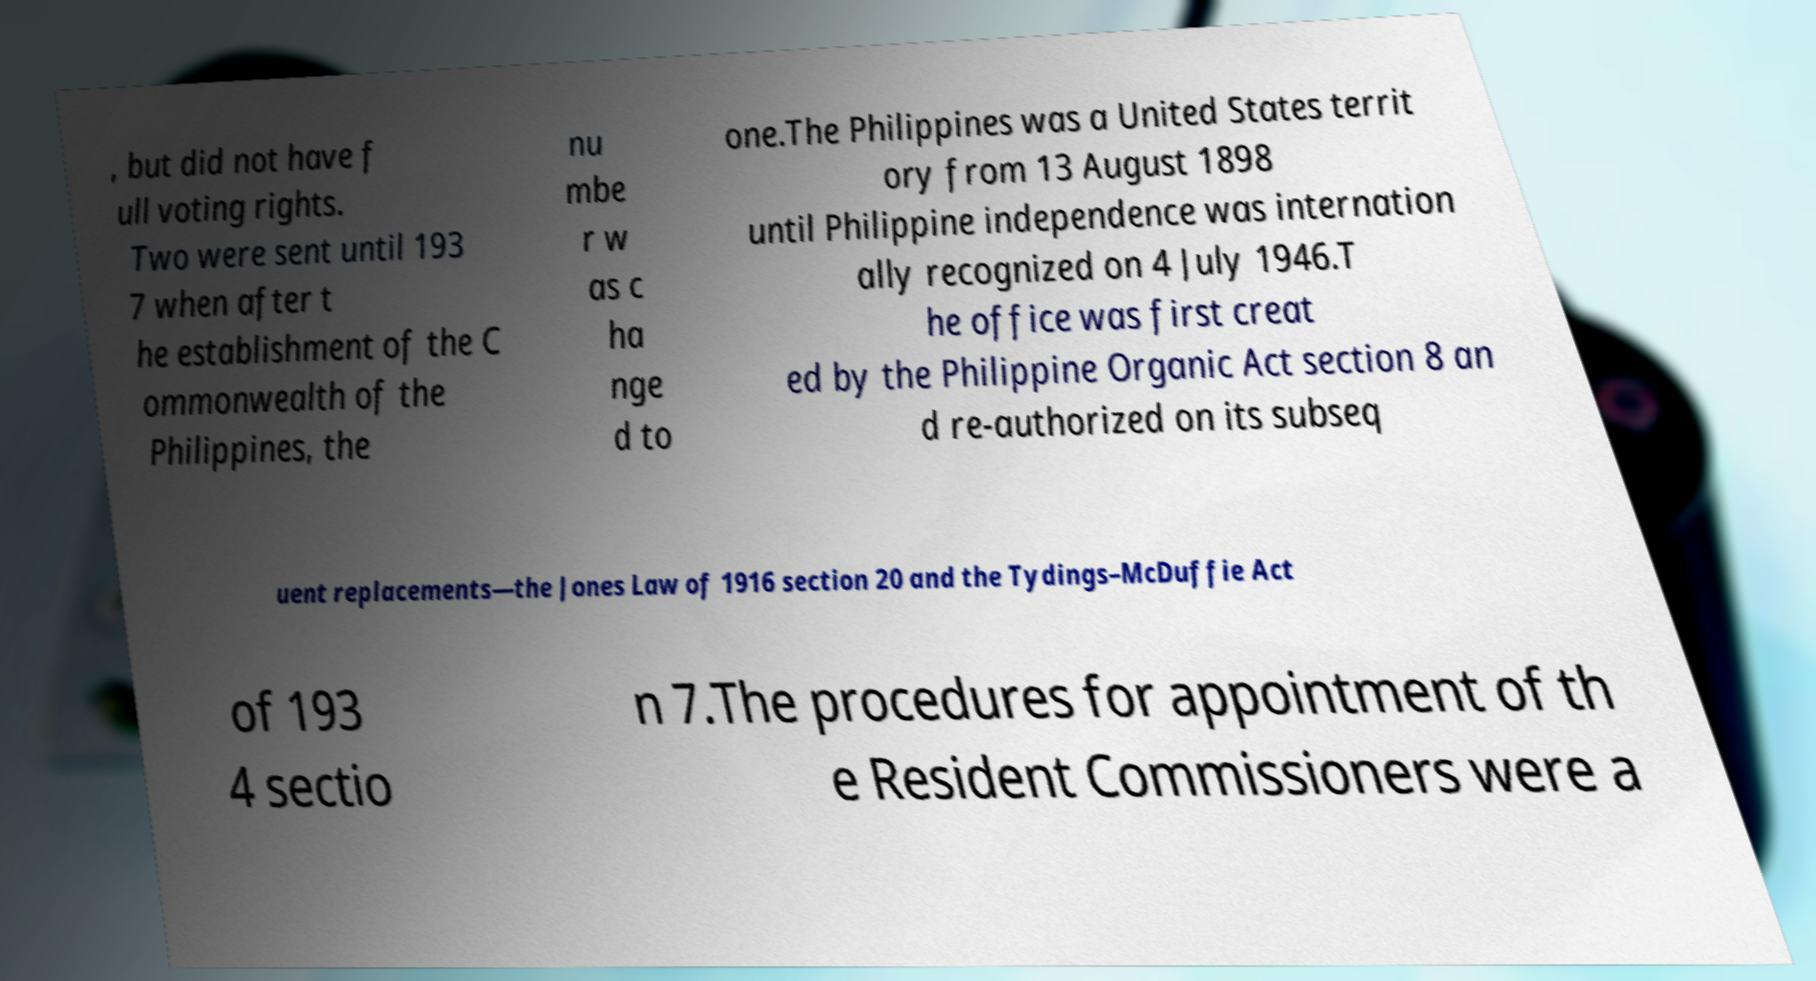There's text embedded in this image that I need extracted. Can you transcribe it verbatim? , but did not have f ull voting rights. Two were sent until 193 7 when after t he establishment of the C ommonwealth of the Philippines, the nu mbe r w as c ha nge d to one.The Philippines was a United States territ ory from 13 August 1898 until Philippine independence was internation ally recognized on 4 July 1946.T he office was first creat ed by the Philippine Organic Act section 8 an d re-authorized on its subseq uent replacements—the Jones Law of 1916 section 20 and the Tydings–McDuffie Act of 193 4 sectio n 7.The procedures for appointment of th e Resident Commissioners were a 